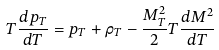<formula> <loc_0><loc_0><loc_500><loc_500>T \frac { d p _ { T } } { d T } = p _ { T } + \rho _ { T } - \frac { M _ { T } ^ { 2 } } 2 T \frac { d M ^ { 2 } } { d T }</formula> 